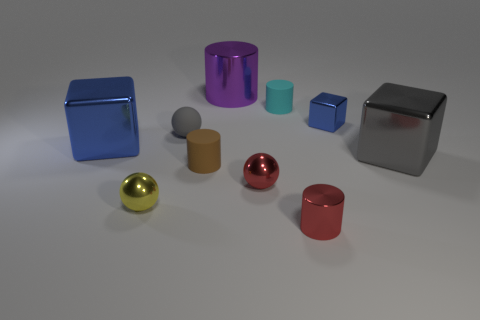Is the color of the big metallic object that is to the left of the small gray object the same as the tiny metallic cube?
Offer a terse response. Yes. Is there a big metal cube that has the same color as the small shiny block?
Offer a very short reply. Yes. The metallic thing that is the same color as the small shiny cylinder is what shape?
Your answer should be very brief. Sphere. How many cyan things are either large cubes or matte cylinders?
Offer a very short reply. 1. There is a gray rubber sphere; are there any tiny red cylinders in front of it?
Offer a very short reply. Yes. There is a gray thing that is left of the tiny red cylinder; is its shape the same as the yellow metal object that is left of the tiny blue shiny object?
Provide a succinct answer. Yes. There is a red object that is the same shape as the purple thing; what material is it?
Your answer should be compact. Metal. What number of cylinders are small brown objects or shiny things?
Ensure brevity in your answer.  3. How many tiny yellow things are made of the same material as the brown thing?
Provide a succinct answer. 0. Do the tiny cylinder that is behind the brown thing and the sphere behind the small red ball have the same material?
Give a very brief answer. Yes. 